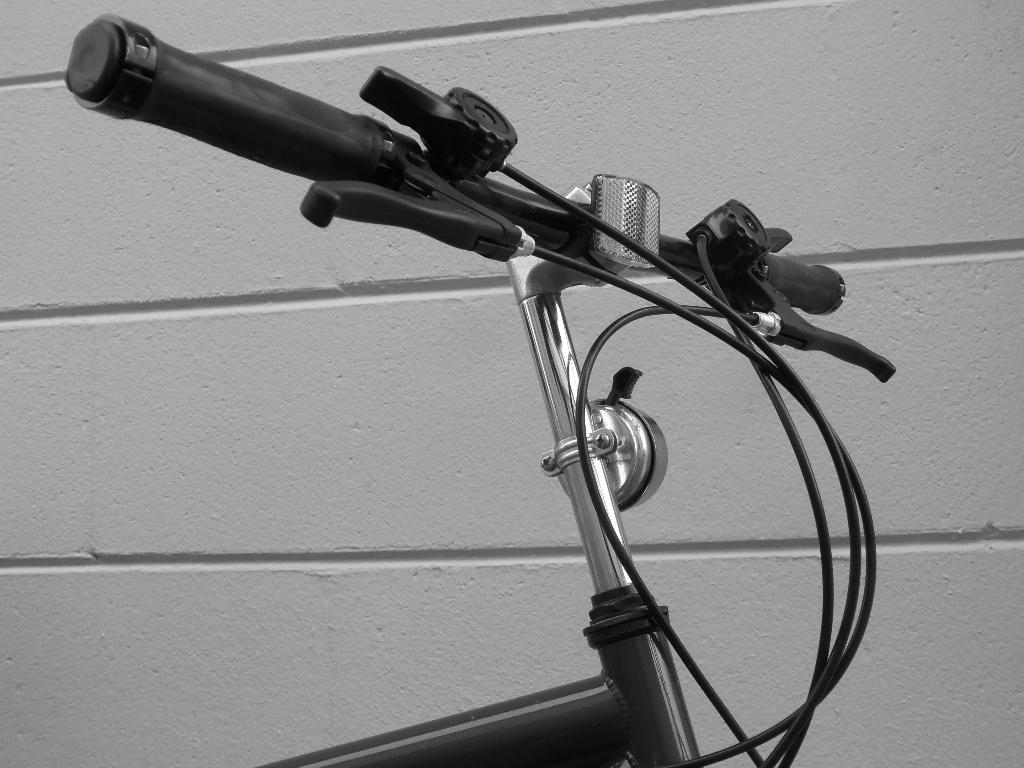What is the main subject of the image? The main subject of the image is a bicycle. How is the bicycle positioned in the image? The bicycle is shown from the front. What can be seen in the background of the image? There is a wall in the background of the image. What type of suit is the laborer wearing while writing in the image? There is no laborer or writing present in the image; it features a bicycle shown from the front with a wall in the background. 